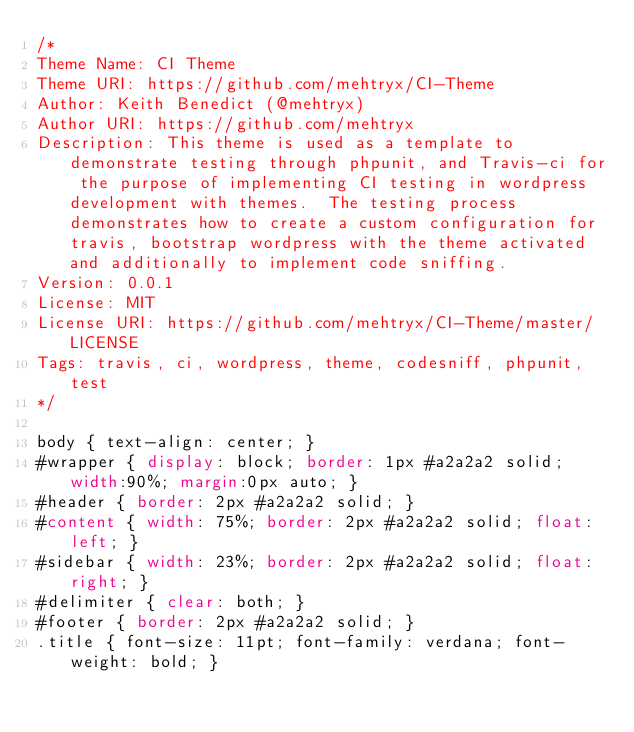Convert code to text. <code><loc_0><loc_0><loc_500><loc_500><_CSS_>/*
Theme Name: CI Theme
Theme URI: https://github.com/mehtryx/CI-Theme
Author: Keith Benedict (@mehtryx)
Author URI: https://github.com/mehtryx
Description: This theme is used as a template to demonstrate testing through phpunit, and Travis-ci for the purpose of implementing CI testing in wordpress development with themes.  The testing process demonstrates how to create a custom configuration for travis, bootstrap wordpress with the theme activated and additionally to implement code sniffing.
Version: 0.0.1
License: MIT
License URI: https://github.com/mehtryx/CI-Theme/master/LICENSE
Tags: travis, ci, wordpress, theme, codesniff, phpunit, test
*/

body { text-align: center; }
#wrapper { display: block; border: 1px #a2a2a2 solid; width:90%; margin:0px auto; }
#header { border: 2px #a2a2a2 solid; }
#content { width: 75%; border: 2px #a2a2a2 solid; float: left; }
#sidebar { width: 23%; border: 2px #a2a2a2 solid; float: right; }
#delimiter { clear: both; }
#footer { border: 2px #a2a2a2 solid; }
.title { font-size: 11pt; font-family: verdana; font-weight: bold; }</code> 